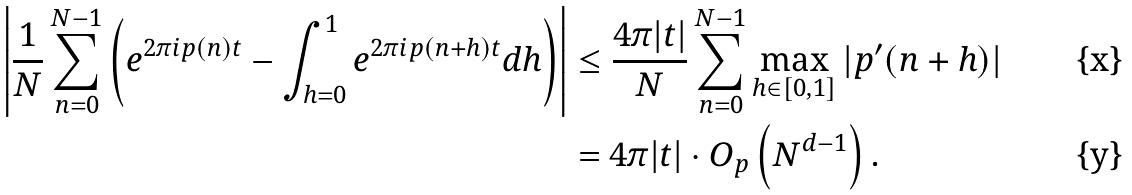Convert formula to latex. <formula><loc_0><loc_0><loc_500><loc_500>\left | \frac { 1 } { N } \sum _ { n = 0 } ^ { N - 1 } \left ( e ^ { 2 \pi i p ( n ) t } - \int _ { h = 0 } ^ { 1 } e ^ { 2 \pi i p ( n + h ) t } d h \right ) \right | & \leq \frac { 4 \pi | t | } { N } \sum _ { n = 0 } ^ { N - 1 } \max _ { h \in \left [ 0 , 1 \right ] } | p ^ { \prime } ( n + h ) | \\ & = 4 \pi | t | \cdot O _ { p } \left ( N ^ { d - 1 } \right ) .</formula> 